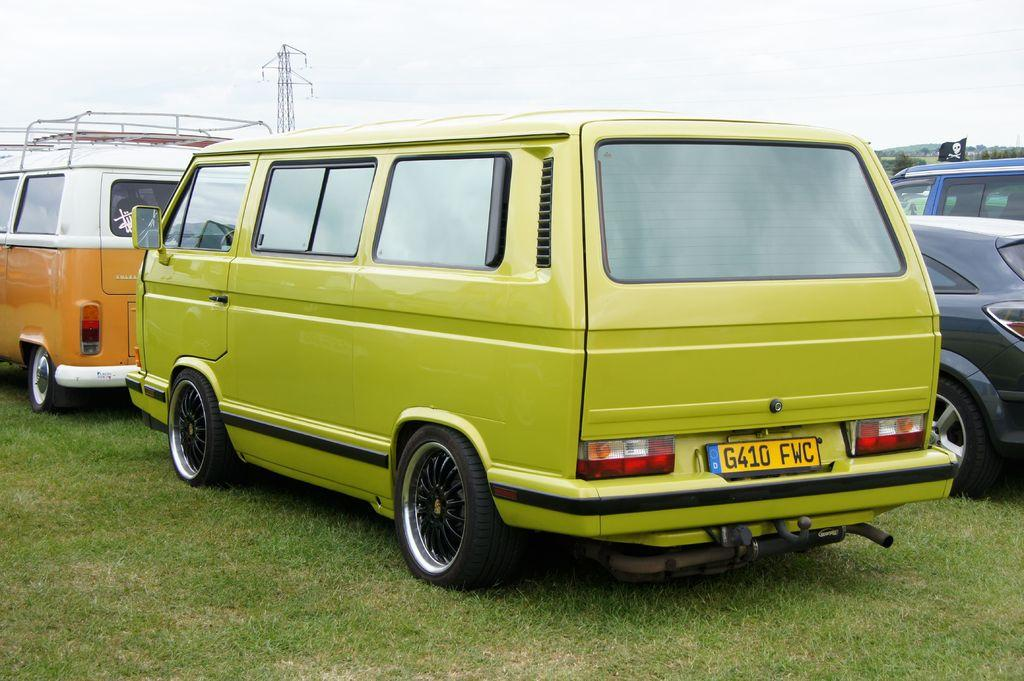<image>
Render a clear and concise summary of the photo. A pea green colored van has the license plate G410 FWC. 